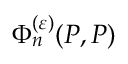<formula> <loc_0><loc_0><loc_500><loc_500>\Phi _ { n } ^ { ( \varepsilon ) } ( P , P )</formula> 